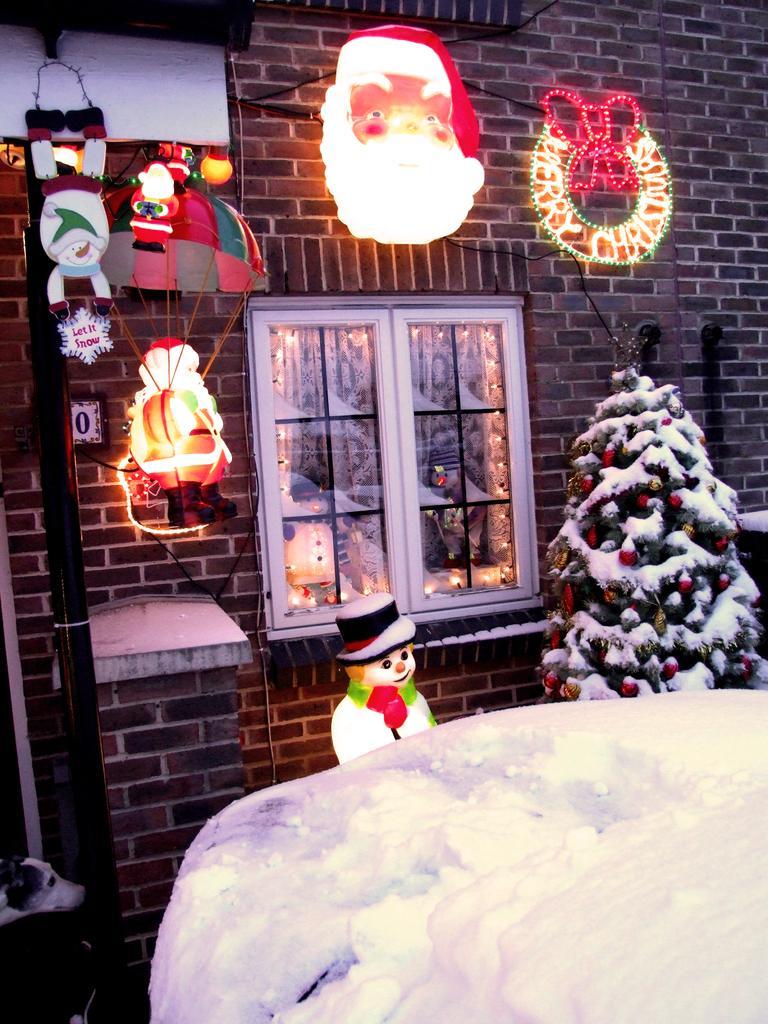Can you describe this image briefly? In this image we can see a building with a window. We can also see a pole, decors on a wall, an umbrella, dolls, lights, snow and a tree decorated with some balls and dolls. 